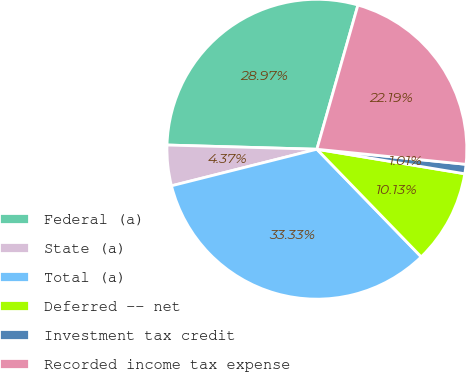Convert chart to OTSL. <chart><loc_0><loc_0><loc_500><loc_500><pie_chart><fcel>Federal (a)<fcel>State (a)<fcel>Total (a)<fcel>Deferred -- net<fcel>Investment tax credit<fcel>Recorded income tax expense<nl><fcel>28.97%<fcel>4.37%<fcel>33.33%<fcel>10.13%<fcel>1.01%<fcel>22.19%<nl></chart> 